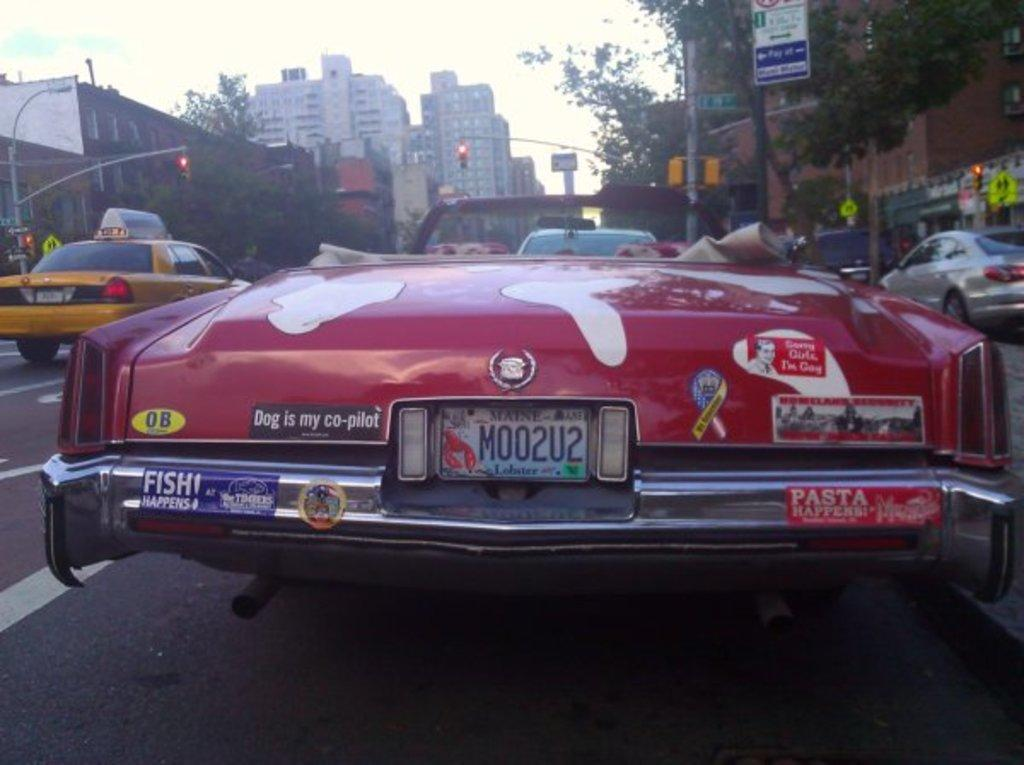Provide a one-sentence caption for the provided image. The back of a red cadilac with several bumper stickers with one reading as dog is my co pilot. 